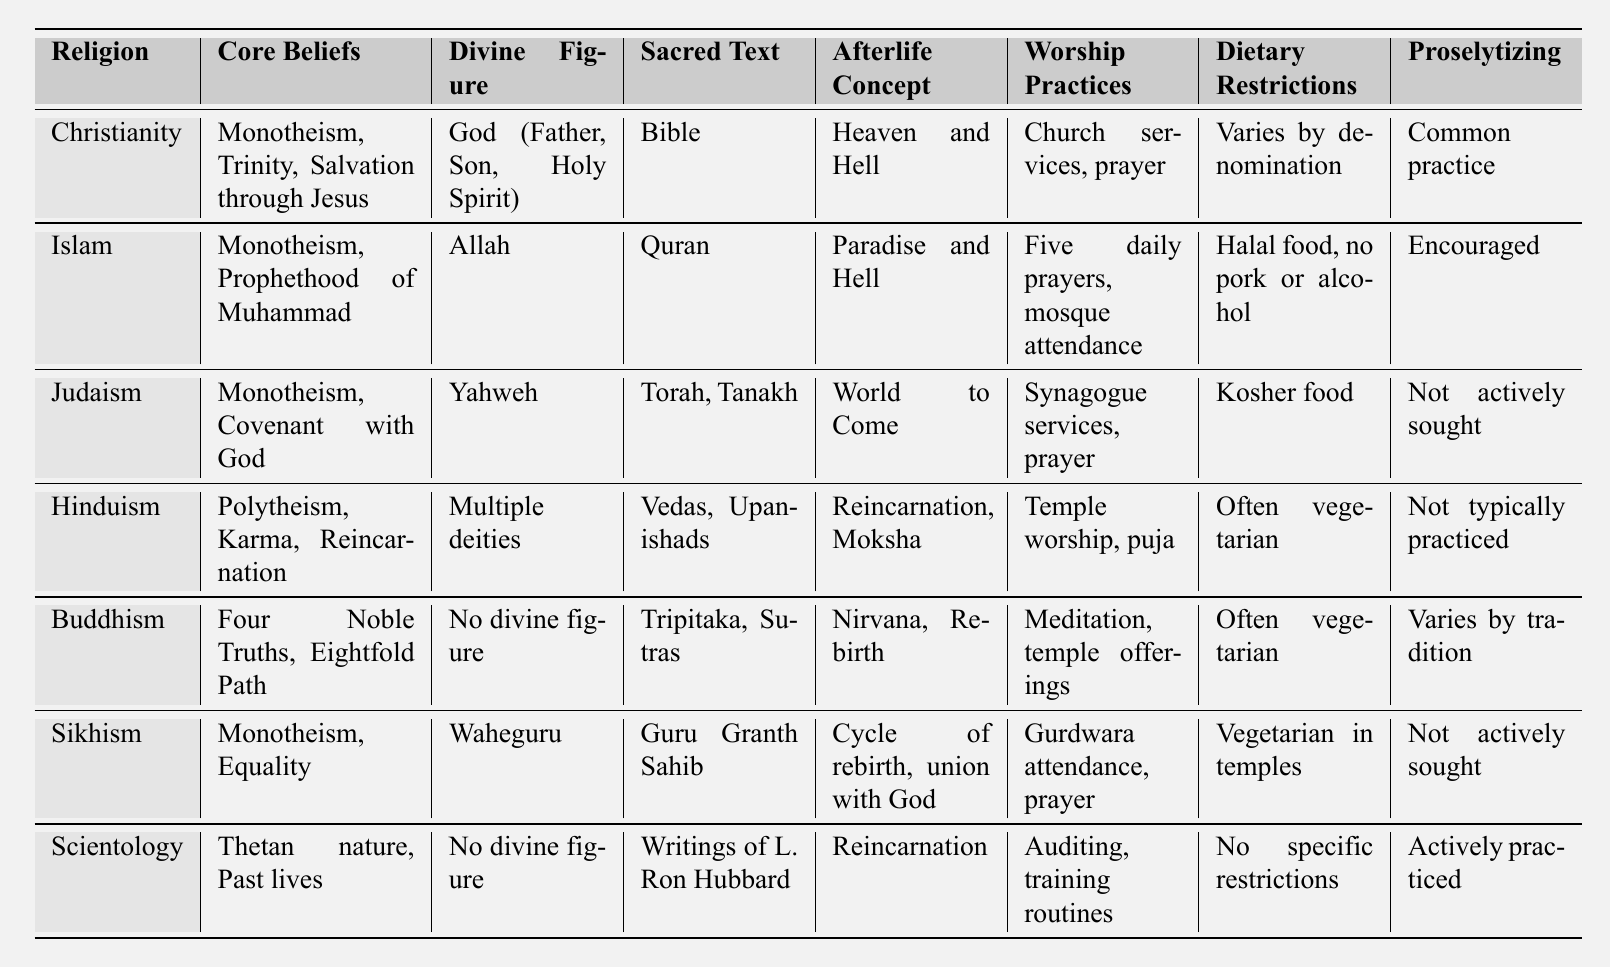What are the core beliefs of Islam? The table lists "Monotheism, Prophethood of Muhammad" as the core beliefs for Islam.
Answer: Monotheism, Prophethood of Muhammad Which religion has a sacred text called the Quran? Looking at the table, Islam is the religion associated with the sacred text named the Quran.
Answer: Islam Does Buddhism have a divine figure? The table indicates that Buddhism does not have a divine figure mentioned.
Answer: No Which religions are associated with the concept of reincarnation? By examining the table, Hinduism, Buddhism, and Scientology all mention reincarnation in their beliefs.
Answer: Hinduism, Buddhism, Scientology What dietary restrictions apply to Islam? According to the table, Islam has dietary restrictions that include "Halal food, no pork or alcohol."
Answer: Halal food, no pork or alcohol Which religion actively practices proselytizing? The table shows that both Islam and Scientology actively practice proselytizing.
Answer: Islam, Scientology How many religions listed have a sacred text? The table shows that all religions except Buddhism (which has "No divine figure") have a sacred text; that would be six out of the seven listed religions.
Answer: 6 Is the afterlife concept of Judaism described as "Heaven and Hell"? By checking the table, the afterlife concept of Judaism is referred to as "World to Come," not "Heaven and Hell."
Answer: No Which religion has the most specific dietary restrictions mentioned? The table shows that Islam has the most specific dietary restrictions detailed in "Halal food, no pork or alcohol." Others like Judaism mention "Kosher food," but Islam is more specific.
Answer: Islam How do the worship practices of Scientology differ from those of Christianity? Comparing the table, Scientology's practices include "Auditing, training routines," while Christianity's practices involve "Church services, prayer." This illustrates a notable difference in worship styles.
Answer: Auditing, training routines vs. Church services, prayer 